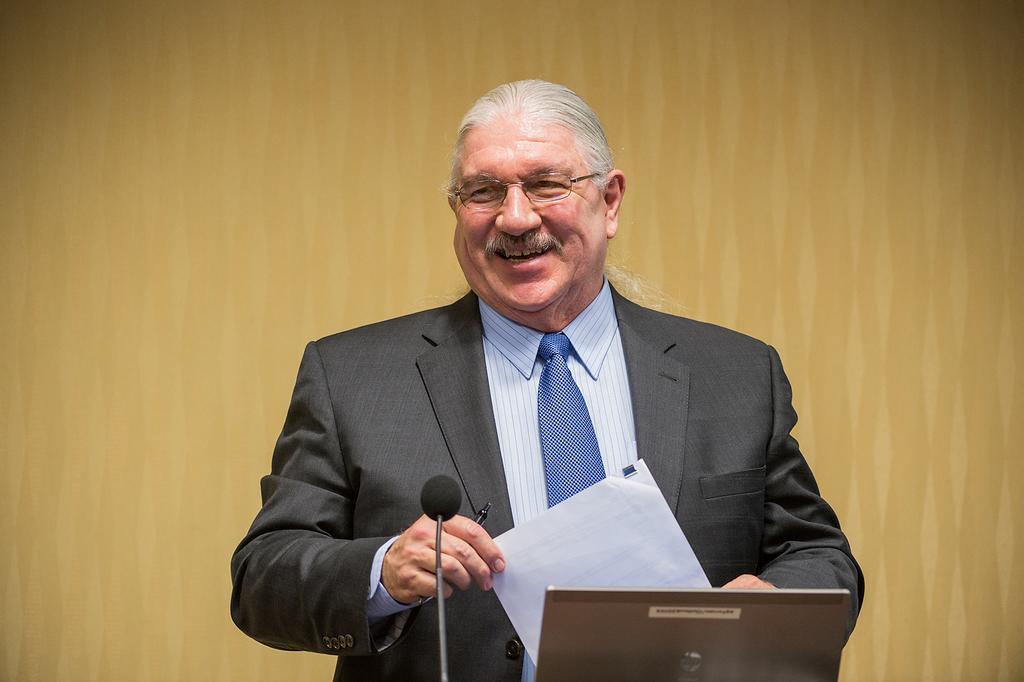Can you describe this image briefly? In this image I can see a person standing wearing black blazer, white shirt, blue color tie. In front I can see a microphone, background the wall is in brown color. 